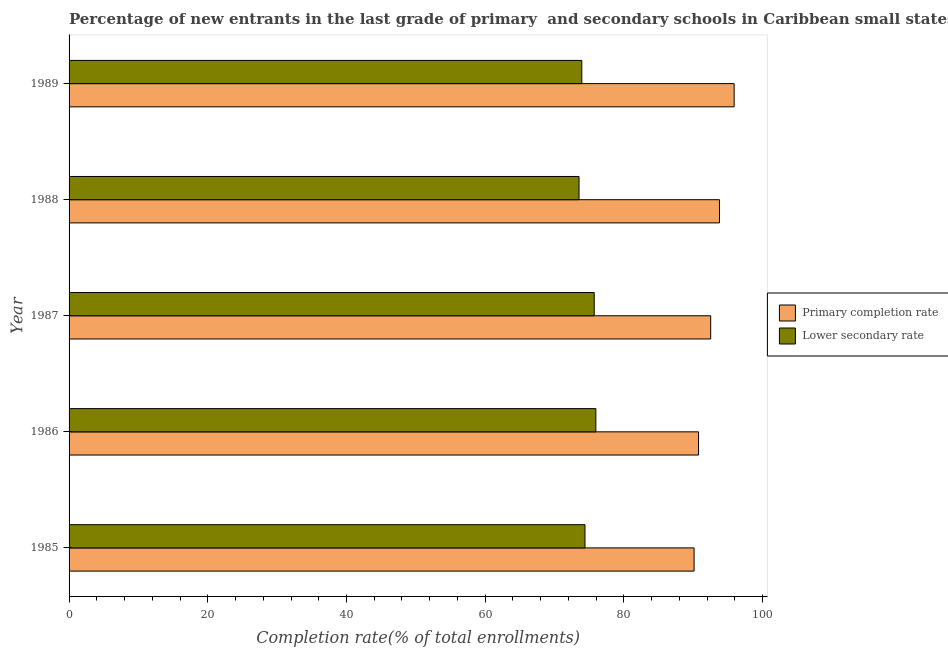How many different coloured bars are there?
Offer a terse response. 2. How many groups of bars are there?
Offer a terse response. 5. How many bars are there on the 1st tick from the top?
Your response must be concise. 2. What is the completion rate in secondary schools in 1986?
Your answer should be very brief. 75.95. Across all years, what is the maximum completion rate in primary schools?
Your answer should be very brief. 95.89. Across all years, what is the minimum completion rate in secondary schools?
Your answer should be very brief. 73.53. In which year was the completion rate in primary schools minimum?
Keep it short and to the point. 1985. What is the total completion rate in secondary schools in the graph?
Make the answer very short. 373.51. What is the difference between the completion rate in secondary schools in 1985 and that in 1989?
Keep it short and to the point. 0.46. What is the difference between the completion rate in primary schools in 1985 and the completion rate in secondary schools in 1987?
Keep it short and to the point. 14.4. What is the average completion rate in primary schools per year?
Offer a very short reply. 92.61. In the year 1986, what is the difference between the completion rate in secondary schools and completion rate in primary schools?
Ensure brevity in your answer.  -14.81. In how many years, is the completion rate in secondary schools greater than 72 %?
Your answer should be compact. 5. Is the completion rate in secondary schools in 1985 less than that in 1987?
Your answer should be very brief. Yes. Is the difference between the completion rate in primary schools in 1987 and 1989 greater than the difference between the completion rate in secondary schools in 1987 and 1989?
Offer a terse response. No. What is the difference between the highest and the second highest completion rate in primary schools?
Your response must be concise. 2.11. What is the difference between the highest and the lowest completion rate in primary schools?
Make the answer very short. 5.77. In how many years, is the completion rate in secondary schools greater than the average completion rate in secondary schools taken over all years?
Offer a terse response. 2. What does the 2nd bar from the top in 1985 represents?
Provide a short and direct response. Primary completion rate. What does the 2nd bar from the bottom in 1989 represents?
Offer a terse response. Lower secondary rate. How many years are there in the graph?
Your answer should be compact. 5. What is the difference between two consecutive major ticks on the X-axis?
Keep it short and to the point. 20. What is the title of the graph?
Offer a terse response. Percentage of new entrants in the last grade of primary  and secondary schools in Caribbean small states. What is the label or title of the X-axis?
Your response must be concise. Completion rate(% of total enrollments). What is the label or title of the Y-axis?
Ensure brevity in your answer.  Year. What is the Completion rate(% of total enrollments) in Primary completion rate in 1985?
Make the answer very short. 90.12. What is the Completion rate(% of total enrollments) in Lower secondary rate in 1985?
Your answer should be compact. 74.39. What is the Completion rate(% of total enrollments) of Primary completion rate in 1986?
Your response must be concise. 90.76. What is the Completion rate(% of total enrollments) of Lower secondary rate in 1986?
Provide a short and direct response. 75.95. What is the Completion rate(% of total enrollments) of Primary completion rate in 1987?
Provide a short and direct response. 92.51. What is the Completion rate(% of total enrollments) in Lower secondary rate in 1987?
Your answer should be very brief. 75.72. What is the Completion rate(% of total enrollments) of Primary completion rate in 1988?
Give a very brief answer. 93.78. What is the Completion rate(% of total enrollments) of Lower secondary rate in 1988?
Ensure brevity in your answer.  73.53. What is the Completion rate(% of total enrollments) of Primary completion rate in 1989?
Provide a short and direct response. 95.89. What is the Completion rate(% of total enrollments) in Lower secondary rate in 1989?
Your answer should be compact. 73.93. Across all years, what is the maximum Completion rate(% of total enrollments) of Primary completion rate?
Offer a terse response. 95.89. Across all years, what is the maximum Completion rate(% of total enrollments) of Lower secondary rate?
Offer a terse response. 75.95. Across all years, what is the minimum Completion rate(% of total enrollments) of Primary completion rate?
Keep it short and to the point. 90.12. Across all years, what is the minimum Completion rate(% of total enrollments) of Lower secondary rate?
Provide a succinct answer. 73.53. What is the total Completion rate(% of total enrollments) in Primary completion rate in the graph?
Make the answer very short. 463.06. What is the total Completion rate(% of total enrollments) in Lower secondary rate in the graph?
Your response must be concise. 373.51. What is the difference between the Completion rate(% of total enrollments) of Primary completion rate in 1985 and that in 1986?
Offer a terse response. -0.64. What is the difference between the Completion rate(% of total enrollments) of Lower secondary rate in 1985 and that in 1986?
Provide a short and direct response. -1.57. What is the difference between the Completion rate(% of total enrollments) in Primary completion rate in 1985 and that in 1987?
Keep it short and to the point. -2.39. What is the difference between the Completion rate(% of total enrollments) of Lower secondary rate in 1985 and that in 1987?
Offer a very short reply. -1.33. What is the difference between the Completion rate(% of total enrollments) in Primary completion rate in 1985 and that in 1988?
Offer a very short reply. -3.66. What is the difference between the Completion rate(% of total enrollments) of Lower secondary rate in 1985 and that in 1988?
Make the answer very short. 0.86. What is the difference between the Completion rate(% of total enrollments) of Primary completion rate in 1985 and that in 1989?
Provide a short and direct response. -5.77. What is the difference between the Completion rate(% of total enrollments) of Lower secondary rate in 1985 and that in 1989?
Your answer should be very brief. 0.46. What is the difference between the Completion rate(% of total enrollments) of Primary completion rate in 1986 and that in 1987?
Your response must be concise. -1.75. What is the difference between the Completion rate(% of total enrollments) of Lower secondary rate in 1986 and that in 1987?
Give a very brief answer. 0.24. What is the difference between the Completion rate(% of total enrollments) of Primary completion rate in 1986 and that in 1988?
Ensure brevity in your answer.  -3.02. What is the difference between the Completion rate(% of total enrollments) of Lower secondary rate in 1986 and that in 1988?
Your answer should be compact. 2.43. What is the difference between the Completion rate(% of total enrollments) in Primary completion rate in 1986 and that in 1989?
Your answer should be very brief. -5.13. What is the difference between the Completion rate(% of total enrollments) of Lower secondary rate in 1986 and that in 1989?
Your answer should be very brief. 2.03. What is the difference between the Completion rate(% of total enrollments) in Primary completion rate in 1987 and that in 1988?
Your answer should be very brief. -1.27. What is the difference between the Completion rate(% of total enrollments) of Lower secondary rate in 1987 and that in 1988?
Provide a succinct answer. 2.19. What is the difference between the Completion rate(% of total enrollments) in Primary completion rate in 1987 and that in 1989?
Give a very brief answer. -3.38. What is the difference between the Completion rate(% of total enrollments) of Lower secondary rate in 1987 and that in 1989?
Ensure brevity in your answer.  1.79. What is the difference between the Completion rate(% of total enrollments) of Primary completion rate in 1988 and that in 1989?
Provide a short and direct response. -2.11. What is the difference between the Completion rate(% of total enrollments) in Lower secondary rate in 1988 and that in 1989?
Your answer should be very brief. -0.4. What is the difference between the Completion rate(% of total enrollments) of Primary completion rate in 1985 and the Completion rate(% of total enrollments) of Lower secondary rate in 1986?
Your answer should be very brief. 14.17. What is the difference between the Completion rate(% of total enrollments) of Primary completion rate in 1985 and the Completion rate(% of total enrollments) of Lower secondary rate in 1987?
Ensure brevity in your answer.  14.4. What is the difference between the Completion rate(% of total enrollments) in Primary completion rate in 1985 and the Completion rate(% of total enrollments) in Lower secondary rate in 1988?
Give a very brief answer. 16.59. What is the difference between the Completion rate(% of total enrollments) in Primary completion rate in 1985 and the Completion rate(% of total enrollments) in Lower secondary rate in 1989?
Provide a short and direct response. 16.19. What is the difference between the Completion rate(% of total enrollments) of Primary completion rate in 1986 and the Completion rate(% of total enrollments) of Lower secondary rate in 1987?
Your answer should be very brief. 15.04. What is the difference between the Completion rate(% of total enrollments) of Primary completion rate in 1986 and the Completion rate(% of total enrollments) of Lower secondary rate in 1988?
Your response must be concise. 17.23. What is the difference between the Completion rate(% of total enrollments) in Primary completion rate in 1986 and the Completion rate(% of total enrollments) in Lower secondary rate in 1989?
Give a very brief answer. 16.83. What is the difference between the Completion rate(% of total enrollments) of Primary completion rate in 1987 and the Completion rate(% of total enrollments) of Lower secondary rate in 1988?
Ensure brevity in your answer.  18.98. What is the difference between the Completion rate(% of total enrollments) in Primary completion rate in 1987 and the Completion rate(% of total enrollments) in Lower secondary rate in 1989?
Your answer should be compact. 18.58. What is the difference between the Completion rate(% of total enrollments) in Primary completion rate in 1988 and the Completion rate(% of total enrollments) in Lower secondary rate in 1989?
Keep it short and to the point. 19.85. What is the average Completion rate(% of total enrollments) in Primary completion rate per year?
Ensure brevity in your answer.  92.61. What is the average Completion rate(% of total enrollments) of Lower secondary rate per year?
Provide a succinct answer. 74.7. In the year 1985, what is the difference between the Completion rate(% of total enrollments) of Primary completion rate and Completion rate(% of total enrollments) of Lower secondary rate?
Offer a very short reply. 15.73. In the year 1986, what is the difference between the Completion rate(% of total enrollments) in Primary completion rate and Completion rate(% of total enrollments) in Lower secondary rate?
Provide a short and direct response. 14.81. In the year 1987, what is the difference between the Completion rate(% of total enrollments) of Primary completion rate and Completion rate(% of total enrollments) of Lower secondary rate?
Your answer should be very brief. 16.79. In the year 1988, what is the difference between the Completion rate(% of total enrollments) in Primary completion rate and Completion rate(% of total enrollments) in Lower secondary rate?
Make the answer very short. 20.25. In the year 1989, what is the difference between the Completion rate(% of total enrollments) of Primary completion rate and Completion rate(% of total enrollments) of Lower secondary rate?
Provide a succinct answer. 21.97. What is the ratio of the Completion rate(% of total enrollments) in Primary completion rate in 1985 to that in 1986?
Provide a succinct answer. 0.99. What is the ratio of the Completion rate(% of total enrollments) of Lower secondary rate in 1985 to that in 1986?
Offer a terse response. 0.98. What is the ratio of the Completion rate(% of total enrollments) of Primary completion rate in 1985 to that in 1987?
Your answer should be compact. 0.97. What is the ratio of the Completion rate(% of total enrollments) of Lower secondary rate in 1985 to that in 1987?
Offer a terse response. 0.98. What is the ratio of the Completion rate(% of total enrollments) in Lower secondary rate in 1985 to that in 1988?
Your answer should be very brief. 1.01. What is the ratio of the Completion rate(% of total enrollments) of Primary completion rate in 1985 to that in 1989?
Offer a terse response. 0.94. What is the ratio of the Completion rate(% of total enrollments) in Primary completion rate in 1986 to that in 1987?
Offer a very short reply. 0.98. What is the ratio of the Completion rate(% of total enrollments) of Primary completion rate in 1986 to that in 1988?
Ensure brevity in your answer.  0.97. What is the ratio of the Completion rate(% of total enrollments) of Lower secondary rate in 1986 to that in 1988?
Ensure brevity in your answer.  1.03. What is the ratio of the Completion rate(% of total enrollments) in Primary completion rate in 1986 to that in 1989?
Give a very brief answer. 0.95. What is the ratio of the Completion rate(% of total enrollments) of Lower secondary rate in 1986 to that in 1989?
Offer a terse response. 1.03. What is the ratio of the Completion rate(% of total enrollments) of Primary completion rate in 1987 to that in 1988?
Give a very brief answer. 0.99. What is the ratio of the Completion rate(% of total enrollments) of Lower secondary rate in 1987 to that in 1988?
Give a very brief answer. 1.03. What is the ratio of the Completion rate(% of total enrollments) in Primary completion rate in 1987 to that in 1989?
Keep it short and to the point. 0.96. What is the ratio of the Completion rate(% of total enrollments) of Lower secondary rate in 1987 to that in 1989?
Make the answer very short. 1.02. What is the difference between the highest and the second highest Completion rate(% of total enrollments) of Primary completion rate?
Offer a very short reply. 2.11. What is the difference between the highest and the second highest Completion rate(% of total enrollments) in Lower secondary rate?
Provide a succinct answer. 0.24. What is the difference between the highest and the lowest Completion rate(% of total enrollments) of Primary completion rate?
Offer a very short reply. 5.77. What is the difference between the highest and the lowest Completion rate(% of total enrollments) in Lower secondary rate?
Your answer should be very brief. 2.43. 